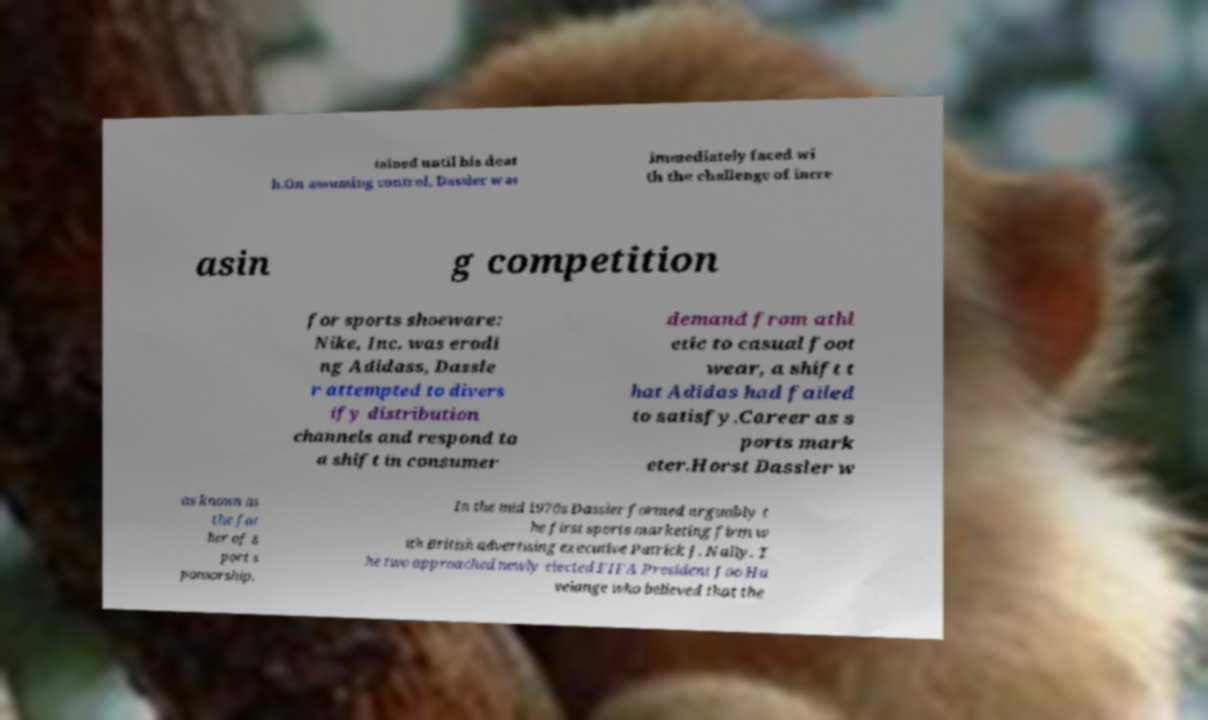What messages or text are displayed in this image? I need them in a readable, typed format. tained until his deat h.On assuming control, Dassler was immediately faced wi th the challenge of incre asin g competition for sports shoeware: Nike, Inc. was erodi ng Adidass, Dassle r attempted to divers ify distribution channels and respond to a shift in consumer demand from athl etic to casual foot wear, a shift t hat Adidas had failed to satisfy.Career as s ports mark eter.Horst Dassler w as known as the fat her of s port s ponsorship. In the mid 1970s Dassler formed arguably t he first sports marketing firm w ith British advertising executive Patrick J. Nally. T he two approached newly elected FIFA President Joo Ha velange who believed that the 